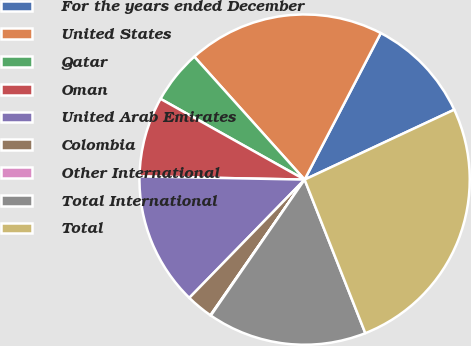Convert chart. <chart><loc_0><loc_0><loc_500><loc_500><pie_chart><fcel>For the years ended December<fcel>United States<fcel>Qatar<fcel>Oman<fcel>United Arab Emirates<fcel>Colombia<fcel>Other International<fcel>Total International<fcel>Total<nl><fcel>10.41%<fcel>19.27%<fcel>5.23%<fcel>7.82%<fcel>13.01%<fcel>2.64%<fcel>0.05%<fcel>15.6%<fcel>25.96%<nl></chart> 